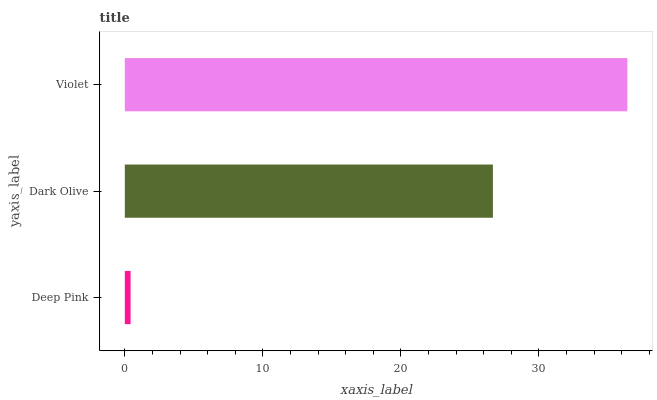Is Deep Pink the minimum?
Answer yes or no. Yes. Is Violet the maximum?
Answer yes or no. Yes. Is Dark Olive the minimum?
Answer yes or no. No. Is Dark Olive the maximum?
Answer yes or no. No. Is Dark Olive greater than Deep Pink?
Answer yes or no. Yes. Is Deep Pink less than Dark Olive?
Answer yes or no. Yes. Is Deep Pink greater than Dark Olive?
Answer yes or no. No. Is Dark Olive less than Deep Pink?
Answer yes or no. No. Is Dark Olive the high median?
Answer yes or no. Yes. Is Dark Olive the low median?
Answer yes or no. Yes. Is Deep Pink the high median?
Answer yes or no. No. Is Violet the low median?
Answer yes or no. No. 